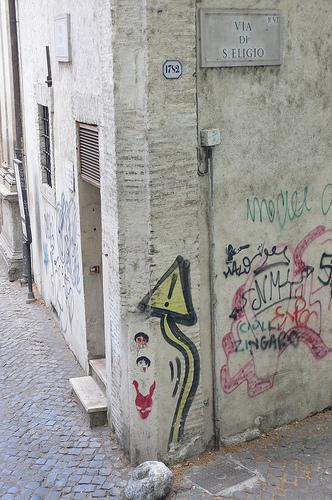How many doorways are visible?
Give a very brief answer. 1. How many stairs are there?
Give a very brief answer. 2. 